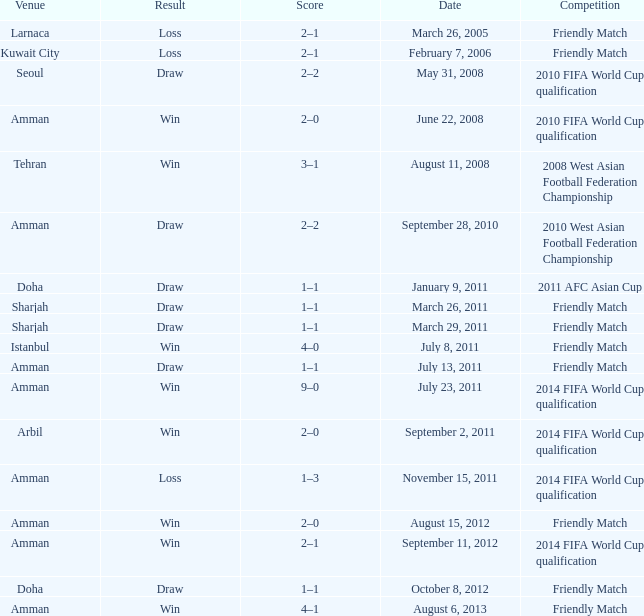During the loss on march 26, 2005, what was the venue where the match was played? Larnaca. 